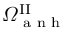Convert formula to latex. <formula><loc_0><loc_0><loc_500><loc_500>\varOmega ^ { I I } _ { a n h }</formula> 